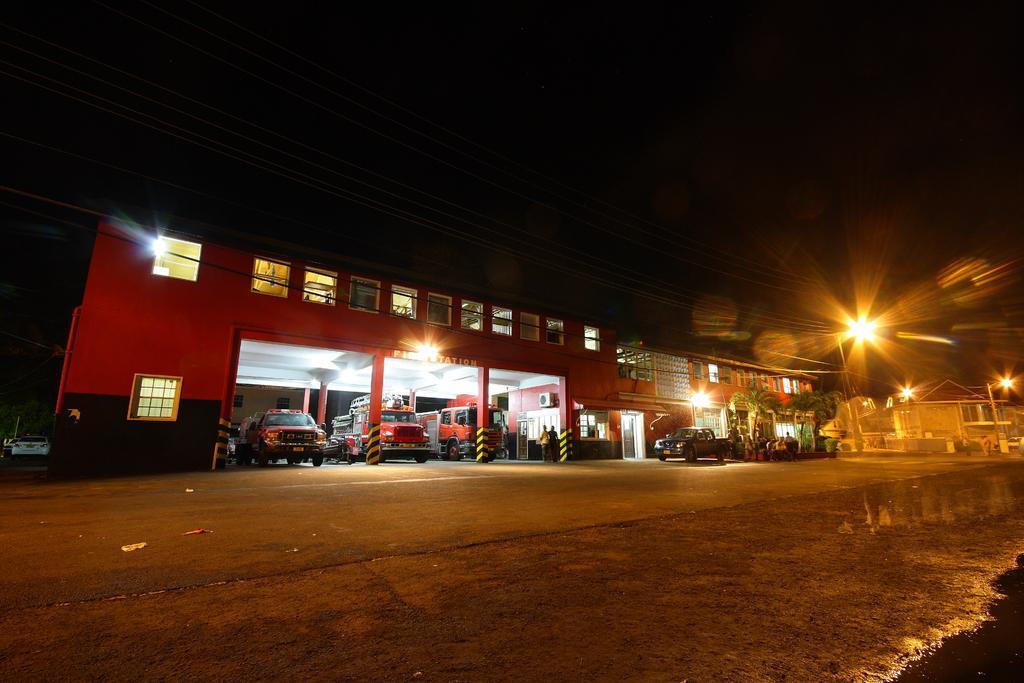Could you give a brief overview of what you see in this image? In this image we can see buildings, windows, wires, light poles, vehicles, cars, also we can see the sky. 